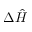<formula> <loc_0><loc_0><loc_500><loc_500>\Delta \hat { H }</formula> 